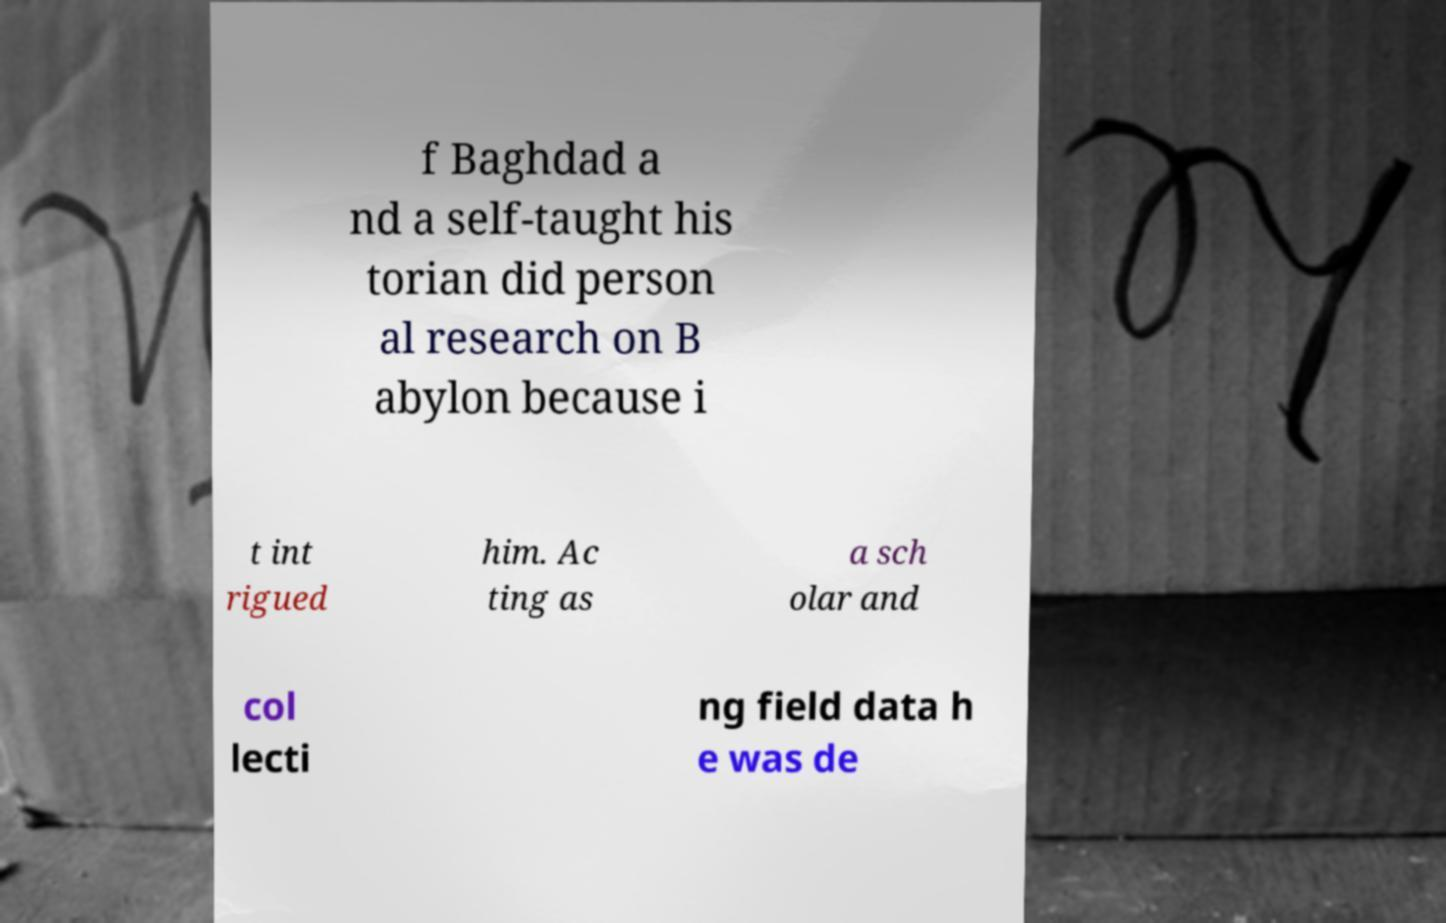Could you extract and type out the text from this image? f Baghdad a nd a self-taught his torian did person al research on B abylon because i t int rigued him. Ac ting as a sch olar and col lecti ng field data h e was de 